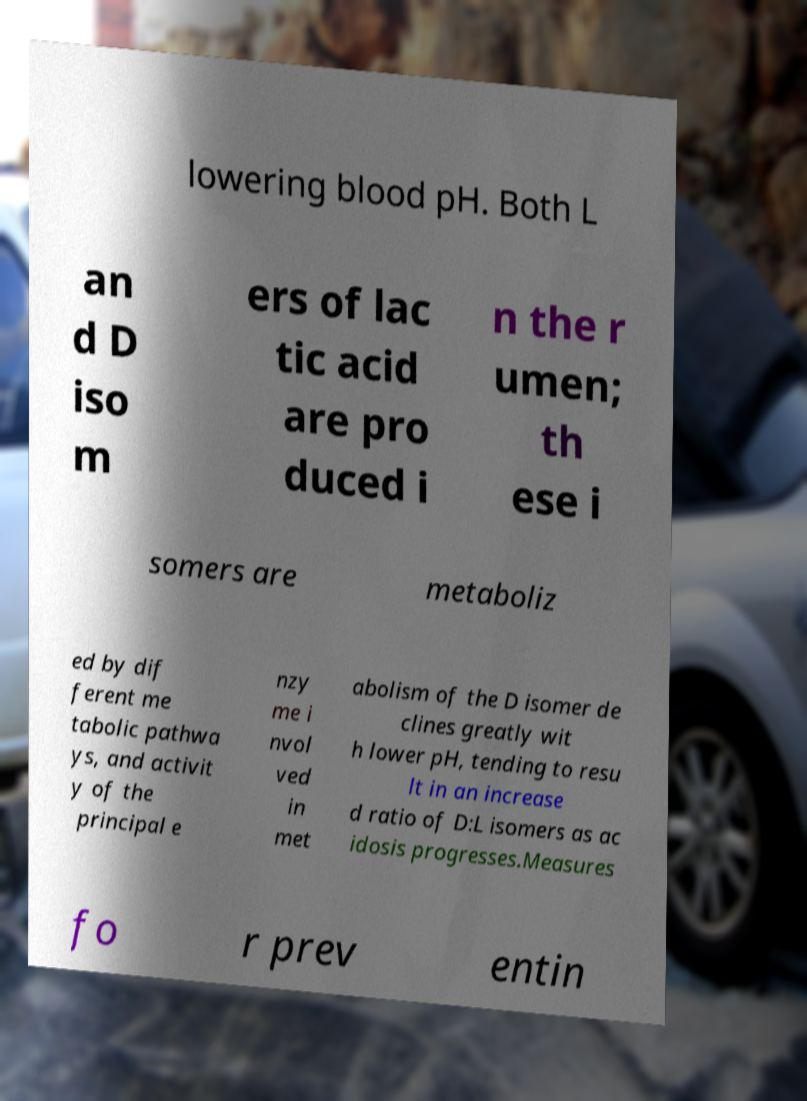What messages or text are displayed in this image? I need them in a readable, typed format. lowering blood pH. Both L an d D iso m ers of lac tic acid are pro duced i n the r umen; th ese i somers are metaboliz ed by dif ferent me tabolic pathwa ys, and activit y of the principal e nzy me i nvol ved in met abolism of the D isomer de clines greatly wit h lower pH, tending to resu lt in an increase d ratio of D:L isomers as ac idosis progresses.Measures fo r prev entin 